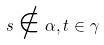<formula> <loc_0><loc_0><loc_500><loc_500>s \notin \alpha , t \in \gamma</formula> 